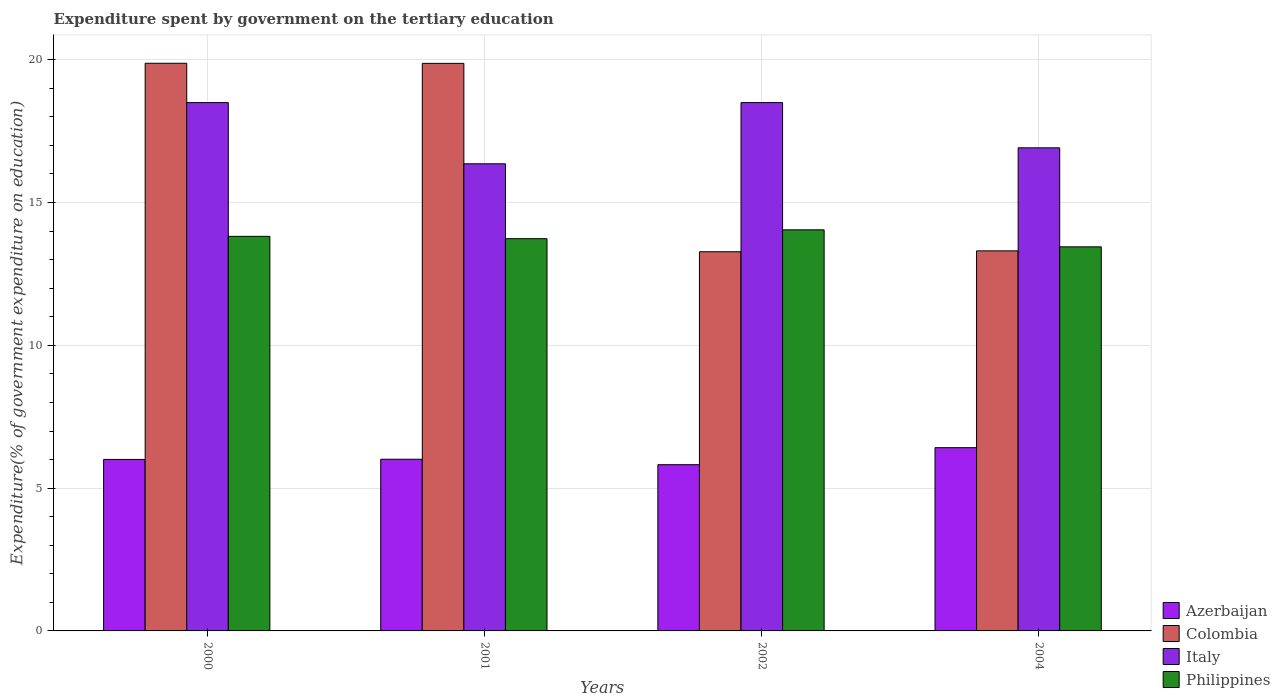How many different coloured bars are there?
Give a very brief answer. 4. How many groups of bars are there?
Offer a very short reply. 4. Are the number of bars per tick equal to the number of legend labels?
Your answer should be compact. Yes. Are the number of bars on each tick of the X-axis equal?
Provide a short and direct response. Yes. How many bars are there on the 4th tick from the left?
Offer a terse response. 4. What is the label of the 2nd group of bars from the left?
Offer a very short reply. 2001. What is the expenditure spent by government on the tertiary education in Philippines in 2004?
Make the answer very short. 13.45. Across all years, what is the maximum expenditure spent by government on the tertiary education in Italy?
Ensure brevity in your answer.  18.5. Across all years, what is the minimum expenditure spent by government on the tertiary education in Azerbaijan?
Make the answer very short. 5.82. In which year was the expenditure spent by government on the tertiary education in Colombia maximum?
Ensure brevity in your answer.  2000. In which year was the expenditure spent by government on the tertiary education in Azerbaijan minimum?
Offer a terse response. 2002. What is the total expenditure spent by government on the tertiary education in Colombia in the graph?
Offer a terse response. 66.34. What is the difference between the expenditure spent by government on the tertiary education in Italy in 2001 and that in 2004?
Provide a succinct answer. -0.56. What is the difference between the expenditure spent by government on the tertiary education in Azerbaijan in 2002 and the expenditure spent by government on the tertiary education in Italy in 2004?
Ensure brevity in your answer.  -11.1. What is the average expenditure spent by government on the tertiary education in Italy per year?
Make the answer very short. 17.57. In the year 2002, what is the difference between the expenditure spent by government on the tertiary education in Azerbaijan and expenditure spent by government on the tertiary education in Colombia?
Provide a succinct answer. -7.46. What is the ratio of the expenditure spent by government on the tertiary education in Azerbaijan in 2000 to that in 2004?
Offer a very short reply. 0.94. Is the expenditure spent by government on the tertiary education in Philippines in 2000 less than that in 2001?
Keep it short and to the point. No. What is the difference between the highest and the second highest expenditure spent by government on the tertiary education in Philippines?
Make the answer very short. 0.23. What is the difference between the highest and the lowest expenditure spent by government on the tertiary education in Colombia?
Ensure brevity in your answer.  6.6. In how many years, is the expenditure spent by government on the tertiary education in Azerbaijan greater than the average expenditure spent by government on the tertiary education in Azerbaijan taken over all years?
Offer a terse response. 1. Is it the case that in every year, the sum of the expenditure spent by government on the tertiary education in Colombia and expenditure spent by government on the tertiary education in Philippines is greater than the sum of expenditure spent by government on the tertiary education in Azerbaijan and expenditure spent by government on the tertiary education in Italy?
Offer a terse response. No. What does the 1st bar from the right in 2001 represents?
Provide a short and direct response. Philippines. Is it the case that in every year, the sum of the expenditure spent by government on the tertiary education in Italy and expenditure spent by government on the tertiary education in Azerbaijan is greater than the expenditure spent by government on the tertiary education in Colombia?
Offer a terse response. Yes. Are all the bars in the graph horizontal?
Keep it short and to the point. No. How many years are there in the graph?
Make the answer very short. 4. Are the values on the major ticks of Y-axis written in scientific E-notation?
Offer a terse response. No. Does the graph contain any zero values?
Keep it short and to the point. No. How are the legend labels stacked?
Your response must be concise. Vertical. What is the title of the graph?
Ensure brevity in your answer.  Expenditure spent by government on the tertiary education. Does "Bhutan" appear as one of the legend labels in the graph?
Your answer should be very brief. No. What is the label or title of the Y-axis?
Keep it short and to the point. Expenditure(% of government expenditure on education). What is the Expenditure(% of government expenditure on education) in Azerbaijan in 2000?
Offer a terse response. 6.01. What is the Expenditure(% of government expenditure on education) in Colombia in 2000?
Provide a succinct answer. 19.88. What is the Expenditure(% of government expenditure on education) in Italy in 2000?
Make the answer very short. 18.5. What is the Expenditure(% of government expenditure on education) of Philippines in 2000?
Your answer should be very brief. 13.82. What is the Expenditure(% of government expenditure on education) of Azerbaijan in 2001?
Make the answer very short. 6.01. What is the Expenditure(% of government expenditure on education) in Colombia in 2001?
Offer a very short reply. 19.87. What is the Expenditure(% of government expenditure on education) in Italy in 2001?
Your answer should be very brief. 16.36. What is the Expenditure(% of government expenditure on education) of Philippines in 2001?
Provide a succinct answer. 13.73. What is the Expenditure(% of government expenditure on education) in Azerbaijan in 2002?
Keep it short and to the point. 5.82. What is the Expenditure(% of government expenditure on education) of Colombia in 2002?
Keep it short and to the point. 13.28. What is the Expenditure(% of government expenditure on education) in Italy in 2002?
Offer a terse response. 18.5. What is the Expenditure(% of government expenditure on education) of Philippines in 2002?
Keep it short and to the point. 14.05. What is the Expenditure(% of government expenditure on education) of Azerbaijan in 2004?
Give a very brief answer. 6.42. What is the Expenditure(% of government expenditure on education) of Colombia in 2004?
Give a very brief answer. 13.31. What is the Expenditure(% of government expenditure on education) in Italy in 2004?
Your answer should be very brief. 16.92. What is the Expenditure(% of government expenditure on education) in Philippines in 2004?
Keep it short and to the point. 13.45. Across all years, what is the maximum Expenditure(% of government expenditure on education) of Azerbaijan?
Ensure brevity in your answer.  6.42. Across all years, what is the maximum Expenditure(% of government expenditure on education) of Colombia?
Provide a succinct answer. 19.88. Across all years, what is the maximum Expenditure(% of government expenditure on education) in Italy?
Keep it short and to the point. 18.5. Across all years, what is the maximum Expenditure(% of government expenditure on education) in Philippines?
Your response must be concise. 14.05. Across all years, what is the minimum Expenditure(% of government expenditure on education) in Azerbaijan?
Make the answer very short. 5.82. Across all years, what is the minimum Expenditure(% of government expenditure on education) of Colombia?
Your answer should be compact. 13.28. Across all years, what is the minimum Expenditure(% of government expenditure on education) in Italy?
Your response must be concise. 16.36. Across all years, what is the minimum Expenditure(% of government expenditure on education) of Philippines?
Give a very brief answer. 13.45. What is the total Expenditure(% of government expenditure on education) of Azerbaijan in the graph?
Provide a short and direct response. 24.25. What is the total Expenditure(% of government expenditure on education) in Colombia in the graph?
Keep it short and to the point. 66.34. What is the total Expenditure(% of government expenditure on education) in Italy in the graph?
Provide a succinct answer. 70.27. What is the total Expenditure(% of government expenditure on education) in Philippines in the graph?
Offer a very short reply. 55.05. What is the difference between the Expenditure(% of government expenditure on education) of Azerbaijan in 2000 and that in 2001?
Your response must be concise. -0.01. What is the difference between the Expenditure(% of government expenditure on education) of Colombia in 2000 and that in 2001?
Keep it short and to the point. 0. What is the difference between the Expenditure(% of government expenditure on education) in Italy in 2000 and that in 2001?
Your response must be concise. 2.14. What is the difference between the Expenditure(% of government expenditure on education) of Philippines in 2000 and that in 2001?
Ensure brevity in your answer.  0.08. What is the difference between the Expenditure(% of government expenditure on education) of Azerbaijan in 2000 and that in 2002?
Provide a succinct answer. 0.19. What is the difference between the Expenditure(% of government expenditure on education) in Colombia in 2000 and that in 2002?
Your answer should be compact. 6.6. What is the difference between the Expenditure(% of government expenditure on education) of Philippines in 2000 and that in 2002?
Your response must be concise. -0.23. What is the difference between the Expenditure(% of government expenditure on education) in Azerbaijan in 2000 and that in 2004?
Ensure brevity in your answer.  -0.41. What is the difference between the Expenditure(% of government expenditure on education) in Colombia in 2000 and that in 2004?
Make the answer very short. 6.57. What is the difference between the Expenditure(% of government expenditure on education) in Italy in 2000 and that in 2004?
Your answer should be very brief. 1.58. What is the difference between the Expenditure(% of government expenditure on education) in Philippines in 2000 and that in 2004?
Provide a succinct answer. 0.37. What is the difference between the Expenditure(% of government expenditure on education) of Azerbaijan in 2001 and that in 2002?
Keep it short and to the point. 0.19. What is the difference between the Expenditure(% of government expenditure on education) of Colombia in 2001 and that in 2002?
Offer a very short reply. 6.6. What is the difference between the Expenditure(% of government expenditure on education) of Italy in 2001 and that in 2002?
Provide a short and direct response. -2.14. What is the difference between the Expenditure(% of government expenditure on education) of Philippines in 2001 and that in 2002?
Offer a very short reply. -0.31. What is the difference between the Expenditure(% of government expenditure on education) of Azerbaijan in 2001 and that in 2004?
Provide a succinct answer. -0.4. What is the difference between the Expenditure(% of government expenditure on education) of Colombia in 2001 and that in 2004?
Give a very brief answer. 6.57. What is the difference between the Expenditure(% of government expenditure on education) of Italy in 2001 and that in 2004?
Ensure brevity in your answer.  -0.56. What is the difference between the Expenditure(% of government expenditure on education) of Philippines in 2001 and that in 2004?
Your answer should be very brief. 0.29. What is the difference between the Expenditure(% of government expenditure on education) in Azerbaijan in 2002 and that in 2004?
Your response must be concise. -0.6. What is the difference between the Expenditure(% of government expenditure on education) of Colombia in 2002 and that in 2004?
Make the answer very short. -0.03. What is the difference between the Expenditure(% of government expenditure on education) in Italy in 2002 and that in 2004?
Give a very brief answer. 1.58. What is the difference between the Expenditure(% of government expenditure on education) in Philippines in 2002 and that in 2004?
Your answer should be very brief. 0.6. What is the difference between the Expenditure(% of government expenditure on education) of Azerbaijan in 2000 and the Expenditure(% of government expenditure on education) of Colombia in 2001?
Make the answer very short. -13.87. What is the difference between the Expenditure(% of government expenditure on education) in Azerbaijan in 2000 and the Expenditure(% of government expenditure on education) in Italy in 2001?
Give a very brief answer. -10.35. What is the difference between the Expenditure(% of government expenditure on education) of Azerbaijan in 2000 and the Expenditure(% of government expenditure on education) of Philippines in 2001?
Keep it short and to the point. -7.73. What is the difference between the Expenditure(% of government expenditure on education) of Colombia in 2000 and the Expenditure(% of government expenditure on education) of Italy in 2001?
Offer a terse response. 3.52. What is the difference between the Expenditure(% of government expenditure on education) of Colombia in 2000 and the Expenditure(% of government expenditure on education) of Philippines in 2001?
Offer a very short reply. 6.14. What is the difference between the Expenditure(% of government expenditure on education) of Italy in 2000 and the Expenditure(% of government expenditure on education) of Philippines in 2001?
Offer a very short reply. 4.76. What is the difference between the Expenditure(% of government expenditure on education) in Azerbaijan in 2000 and the Expenditure(% of government expenditure on education) in Colombia in 2002?
Your response must be concise. -7.27. What is the difference between the Expenditure(% of government expenditure on education) of Azerbaijan in 2000 and the Expenditure(% of government expenditure on education) of Italy in 2002?
Make the answer very short. -12.49. What is the difference between the Expenditure(% of government expenditure on education) in Azerbaijan in 2000 and the Expenditure(% of government expenditure on education) in Philippines in 2002?
Offer a terse response. -8.04. What is the difference between the Expenditure(% of government expenditure on education) of Colombia in 2000 and the Expenditure(% of government expenditure on education) of Italy in 2002?
Your response must be concise. 1.38. What is the difference between the Expenditure(% of government expenditure on education) of Colombia in 2000 and the Expenditure(% of government expenditure on education) of Philippines in 2002?
Provide a succinct answer. 5.83. What is the difference between the Expenditure(% of government expenditure on education) of Italy in 2000 and the Expenditure(% of government expenditure on education) of Philippines in 2002?
Provide a succinct answer. 4.45. What is the difference between the Expenditure(% of government expenditure on education) of Azerbaijan in 2000 and the Expenditure(% of government expenditure on education) of Colombia in 2004?
Offer a terse response. -7.3. What is the difference between the Expenditure(% of government expenditure on education) of Azerbaijan in 2000 and the Expenditure(% of government expenditure on education) of Italy in 2004?
Provide a short and direct response. -10.91. What is the difference between the Expenditure(% of government expenditure on education) in Azerbaijan in 2000 and the Expenditure(% of government expenditure on education) in Philippines in 2004?
Give a very brief answer. -7.44. What is the difference between the Expenditure(% of government expenditure on education) in Colombia in 2000 and the Expenditure(% of government expenditure on education) in Italy in 2004?
Offer a very short reply. 2.96. What is the difference between the Expenditure(% of government expenditure on education) in Colombia in 2000 and the Expenditure(% of government expenditure on education) in Philippines in 2004?
Your response must be concise. 6.43. What is the difference between the Expenditure(% of government expenditure on education) of Italy in 2000 and the Expenditure(% of government expenditure on education) of Philippines in 2004?
Keep it short and to the point. 5.05. What is the difference between the Expenditure(% of government expenditure on education) of Azerbaijan in 2001 and the Expenditure(% of government expenditure on education) of Colombia in 2002?
Offer a terse response. -7.27. What is the difference between the Expenditure(% of government expenditure on education) in Azerbaijan in 2001 and the Expenditure(% of government expenditure on education) in Italy in 2002?
Give a very brief answer. -12.49. What is the difference between the Expenditure(% of government expenditure on education) of Azerbaijan in 2001 and the Expenditure(% of government expenditure on education) of Philippines in 2002?
Your answer should be very brief. -8.03. What is the difference between the Expenditure(% of government expenditure on education) in Colombia in 2001 and the Expenditure(% of government expenditure on education) in Italy in 2002?
Ensure brevity in your answer.  1.37. What is the difference between the Expenditure(% of government expenditure on education) of Colombia in 2001 and the Expenditure(% of government expenditure on education) of Philippines in 2002?
Offer a terse response. 5.83. What is the difference between the Expenditure(% of government expenditure on education) in Italy in 2001 and the Expenditure(% of government expenditure on education) in Philippines in 2002?
Provide a succinct answer. 2.31. What is the difference between the Expenditure(% of government expenditure on education) of Azerbaijan in 2001 and the Expenditure(% of government expenditure on education) of Colombia in 2004?
Your answer should be very brief. -7.3. What is the difference between the Expenditure(% of government expenditure on education) of Azerbaijan in 2001 and the Expenditure(% of government expenditure on education) of Italy in 2004?
Provide a short and direct response. -10.9. What is the difference between the Expenditure(% of government expenditure on education) of Azerbaijan in 2001 and the Expenditure(% of government expenditure on education) of Philippines in 2004?
Offer a terse response. -7.44. What is the difference between the Expenditure(% of government expenditure on education) in Colombia in 2001 and the Expenditure(% of government expenditure on education) in Italy in 2004?
Offer a very short reply. 2.96. What is the difference between the Expenditure(% of government expenditure on education) of Colombia in 2001 and the Expenditure(% of government expenditure on education) of Philippines in 2004?
Your response must be concise. 6.43. What is the difference between the Expenditure(% of government expenditure on education) in Italy in 2001 and the Expenditure(% of government expenditure on education) in Philippines in 2004?
Keep it short and to the point. 2.91. What is the difference between the Expenditure(% of government expenditure on education) of Azerbaijan in 2002 and the Expenditure(% of government expenditure on education) of Colombia in 2004?
Make the answer very short. -7.49. What is the difference between the Expenditure(% of government expenditure on education) in Azerbaijan in 2002 and the Expenditure(% of government expenditure on education) in Italy in 2004?
Provide a succinct answer. -11.1. What is the difference between the Expenditure(% of government expenditure on education) of Azerbaijan in 2002 and the Expenditure(% of government expenditure on education) of Philippines in 2004?
Your answer should be very brief. -7.63. What is the difference between the Expenditure(% of government expenditure on education) of Colombia in 2002 and the Expenditure(% of government expenditure on education) of Italy in 2004?
Offer a very short reply. -3.64. What is the difference between the Expenditure(% of government expenditure on education) of Colombia in 2002 and the Expenditure(% of government expenditure on education) of Philippines in 2004?
Ensure brevity in your answer.  -0.17. What is the difference between the Expenditure(% of government expenditure on education) of Italy in 2002 and the Expenditure(% of government expenditure on education) of Philippines in 2004?
Offer a terse response. 5.05. What is the average Expenditure(% of government expenditure on education) of Azerbaijan per year?
Give a very brief answer. 6.06. What is the average Expenditure(% of government expenditure on education) of Colombia per year?
Provide a short and direct response. 16.58. What is the average Expenditure(% of government expenditure on education) in Italy per year?
Provide a succinct answer. 17.57. What is the average Expenditure(% of government expenditure on education) in Philippines per year?
Your answer should be very brief. 13.76. In the year 2000, what is the difference between the Expenditure(% of government expenditure on education) in Azerbaijan and Expenditure(% of government expenditure on education) in Colombia?
Your answer should be compact. -13.87. In the year 2000, what is the difference between the Expenditure(% of government expenditure on education) in Azerbaijan and Expenditure(% of government expenditure on education) in Italy?
Offer a very short reply. -12.49. In the year 2000, what is the difference between the Expenditure(% of government expenditure on education) in Azerbaijan and Expenditure(% of government expenditure on education) in Philippines?
Make the answer very short. -7.81. In the year 2000, what is the difference between the Expenditure(% of government expenditure on education) in Colombia and Expenditure(% of government expenditure on education) in Italy?
Provide a succinct answer. 1.38. In the year 2000, what is the difference between the Expenditure(% of government expenditure on education) in Colombia and Expenditure(% of government expenditure on education) in Philippines?
Keep it short and to the point. 6.06. In the year 2000, what is the difference between the Expenditure(% of government expenditure on education) in Italy and Expenditure(% of government expenditure on education) in Philippines?
Give a very brief answer. 4.68. In the year 2001, what is the difference between the Expenditure(% of government expenditure on education) in Azerbaijan and Expenditure(% of government expenditure on education) in Colombia?
Provide a succinct answer. -13.86. In the year 2001, what is the difference between the Expenditure(% of government expenditure on education) of Azerbaijan and Expenditure(% of government expenditure on education) of Italy?
Keep it short and to the point. -10.35. In the year 2001, what is the difference between the Expenditure(% of government expenditure on education) of Azerbaijan and Expenditure(% of government expenditure on education) of Philippines?
Provide a succinct answer. -7.72. In the year 2001, what is the difference between the Expenditure(% of government expenditure on education) in Colombia and Expenditure(% of government expenditure on education) in Italy?
Your answer should be compact. 3.52. In the year 2001, what is the difference between the Expenditure(% of government expenditure on education) of Colombia and Expenditure(% of government expenditure on education) of Philippines?
Provide a short and direct response. 6.14. In the year 2001, what is the difference between the Expenditure(% of government expenditure on education) of Italy and Expenditure(% of government expenditure on education) of Philippines?
Your response must be concise. 2.62. In the year 2002, what is the difference between the Expenditure(% of government expenditure on education) of Azerbaijan and Expenditure(% of government expenditure on education) of Colombia?
Ensure brevity in your answer.  -7.46. In the year 2002, what is the difference between the Expenditure(% of government expenditure on education) in Azerbaijan and Expenditure(% of government expenditure on education) in Italy?
Give a very brief answer. -12.68. In the year 2002, what is the difference between the Expenditure(% of government expenditure on education) in Azerbaijan and Expenditure(% of government expenditure on education) in Philippines?
Offer a terse response. -8.22. In the year 2002, what is the difference between the Expenditure(% of government expenditure on education) of Colombia and Expenditure(% of government expenditure on education) of Italy?
Offer a terse response. -5.22. In the year 2002, what is the difference between the Expenditure(% of government expenditure on education) of Colombia and Expenditure(% of government expenditure on education) of Philippines?
Provide a short and direct response. -0.77. In the year 2002, what is the difference between the Expenditure(% of government expenditure on education) in Italy and Expenditure(% of government expenditure on education) in Philippines?
Keep it short and to the point. 4.45. In the year 2004, what is the difference between the Expenditure(% of government expenditure on education) in Azerbaijan and Expenditure(% of government expenditure on education) in Colombia?
Your answer should be compact. -6.89. In the year 2004, what is the difference between the Expenditure(% of government expenditure on education) in Azerbaijan and Expenditure(% of government expenditure on education) in Italy?
Provide a succinct answer. -10.5. In the year 2004, what is the difference between the Expenditure(% of government expenditure on education) in Azerbaijan and Expenditure(% of government expenditure on education) in Philippines?
Your answer should be compact. -7.03. In the year 2004, what is the difference between the Expenditure(% of government expenditure on education) of Colombia and Expenditure(% of government expenditure on education) of Italy?
Your response must be concise. -3.61. In the year 2004, what is the difference between the Expenditure(% of government expenditure on education) in Colombia and Expenditure(% of government expenditure on education) in Philippines?
Provide a short and direct response. -0.14. In the year 2004, what is the difference between the Expenditure(% of government expenditure on education) in Italy and Expenditure(% of government expenditure on education) in Philippines?
Keep it short and to the point. 3.47. What is the ratio of the Expenditure(% of government expenditure on education) in Italy in 2000 to that in 2001?
Give a very brief answer. 1.13. What is the ratio of the Expenditure(% of government expenditure on education) of Philippines in 2000 to that in 2001?
Your answer should be very brief. 1.01. What is the ratio of the Expenditure(% of government expenditure on education) in Azerbaijan in 2000 to that in 2002?
Give a very brief answer. 1.03. What is the ratio of the Expenditure(% of government expenditure on education) of Colombia in 2000 to that in 2002?
Your answer should be very brief. 1.5. What is the ratio of the Expenditure(% of government expenditure on education) in Philippines in 2000 to that in 2002?
Offer a very short reply. 0.98. What is the ratio of the Expenditure(% of government expenditure on education) of Azerbaijan in 2000 to that in 2004?
Make the answer very short. 0.94. What is the ratio of the Expenditure(% of government expenditure on education) in Colombia in 2000 to that in 2004?
Your response must be concise. 1.49. What is the ratio of the Expenditure(% of government expenditure on education) of Italy in 2000 to that in 2004?
Make the answer very short. 1.09. What is the ratio of the Expenditure(% of government expenditure on education) of Philippines in 2000 to that in 2004?
Offer a very short reply. 1.03. What is the ratio of the Expenditure(% of government expenditure on education) of Azerbaijan in 2001 to that in 2002?
Ensure brevity in your answer.  1.03. What is the ratio of the Expenditure(% of government expenditure on education) in Colombia in 2001 to that in 2002?
Provide a short and direct response. 1.5. What is the ratio of the Expenditure(% of government expenditure on education) of Italy in 2001 to that in 2002?
Keep it short and to the point. 0.88. What is the ratio of the Expenditure(% of government expenditure on education) in Philippines in 2001 to that in 2002?
Provide a succinct answer. 0.98. What is the ratio of the Expenditure(% of government expenditure on education) in Azerbaijan in 2001 to that in 2004?
Your response must be concise. 0.94. What is the ratio of the Expenditure(% of government expenditure on education) in Colombia in 2001 to that in 2004?
Offer a very short reply. 1.49. What is the ratio of the Expenditure(% of government expenditure on education) in Italy in 2001 to that in 2004?
Give a very brief answer. 0.97. What is the ratio of the Expenditure(% of government expenditure on education) in Philippines in 2001 to that in 2004?
Give a very brief answer. 1.02. What is the ratio of the Expenditure(% of government expenditure on education) in Azerbaijan in 2002 to that in 2004?
Your response must be concise. 0.91. What is the ratio of the Expenditure(% of government expenditure on education) in Italy in 2002 to that in 2004?
Your answer should be very brief. 1.09. What is the ratio of the Expenditure(% of government expenditure on education) in Philippines in 2002 to that in 2004?
Your answer should be very brief. 1.04. What is the difference between the highest and the second highest Expenditure(% of government expenditure on education) of Azerbaijan?
Provide a short and direct response. 0.4. What is the difference between the highest and the second highest Expenditure(% of government expenditure on education) in Colombia?
Give a very brief answer. 0. What is the difference between the highest and the second highest Expenditure(% of government expenditure on education) of Philippines?
Provide a short and direct response. 0.23. What is the difference between the highest and the lowest Expenditure(% of government expenditure on education) in Azerbaijan?
Give a very brief answer. 0.6. What is the difference between the highest and the lowest Expenditure(% of government expenditure on education) in Colombia?
Ensure brevity in your answer.  6.6. What is the difference between the highest and the lowest Expenditure(% of government expenditure on education) in Italy?
Give a very brief answer. 2.14. What is the difference between the highest and the lowest Expenditure(% of government expenditure on education) of Philippines?
Your response must be concise. 0.6. 